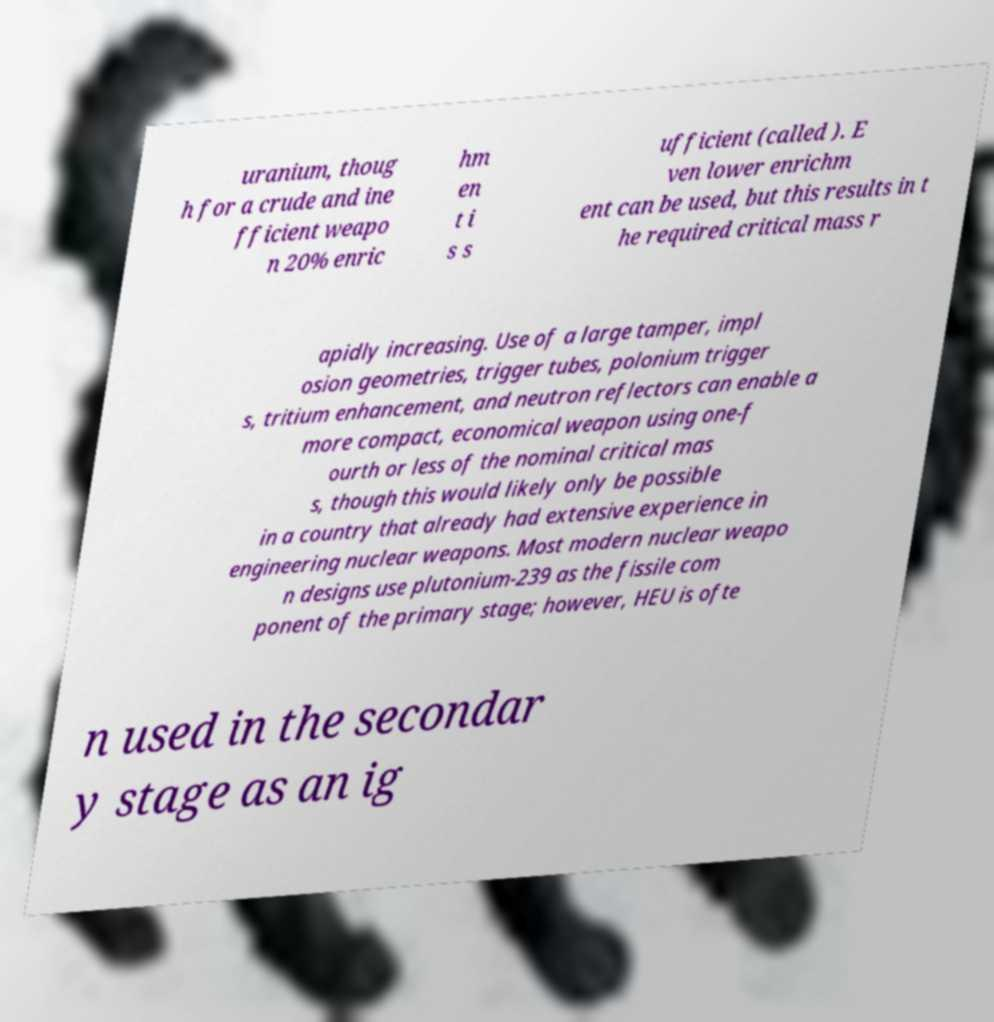Please read and relay the text visible in this image. What does it say? uranium, thoug h for a crude and ine fficient weapo n 20% enric hm en t i s s ufficient (called ). E ven lower enrichm ent can be used, but this results in t he required critical mass r apidly increasing. Use of a large tamper, impl osion geometries, trigger tubes, polonium trigger s, tritium enhancement, and neutron reflectors can enable a more compact, economical weapon using one-f ourth or less of the nominal critical mas s, though this would likely only be possible in a country that already had extensive experience in engineering nuclear weapons. Most modern nuclear weapo n designs use plutonium-239 as the fissile com ponent of the primary stage; however, HEU is ofte n used in the secondar y stage as an ig 